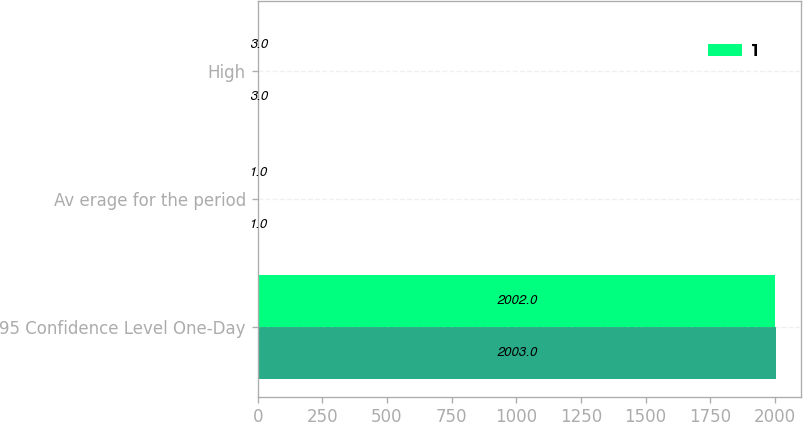Convert chart. <chart><loc_0><loc_0><loc_500><loc_500><stacked_bar_chart><ecel><fcel>95 Confidence Level One-Day<fcel>Av erage for the period<fcel>High<nl><fcel>nan<fcel>2003<fcel>1<fcel>3<nl><fcel>1<fcel>2002<fcel>1<fcel>3<nl></chart> 